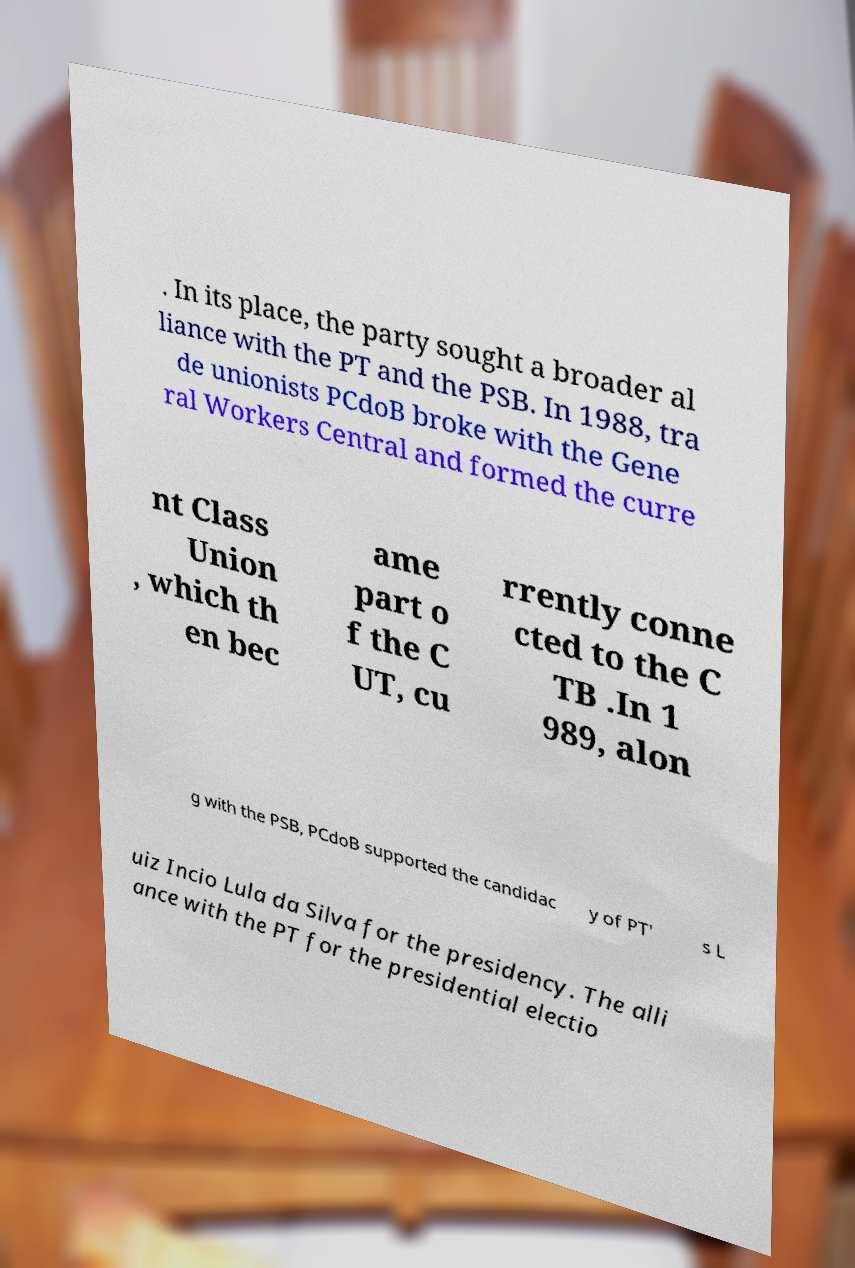Please read and relay the text visible in this image. What does it say? . In its place, the party sought a broader al liance with the PT and the PSB. In 1988, tra de unionists PCdoB broke with the Gene ral Workers Central and formed the curre nt Class Union , which th en bec ame part o f the C UT, cu rrently conne cted to the C TB .In 1 989, alon g with the PSB, PCdoB supported the candidac y of PT' s L uiz Incio Lula da Silva for the presidency. The alli ance with the PT for the presidential electio 